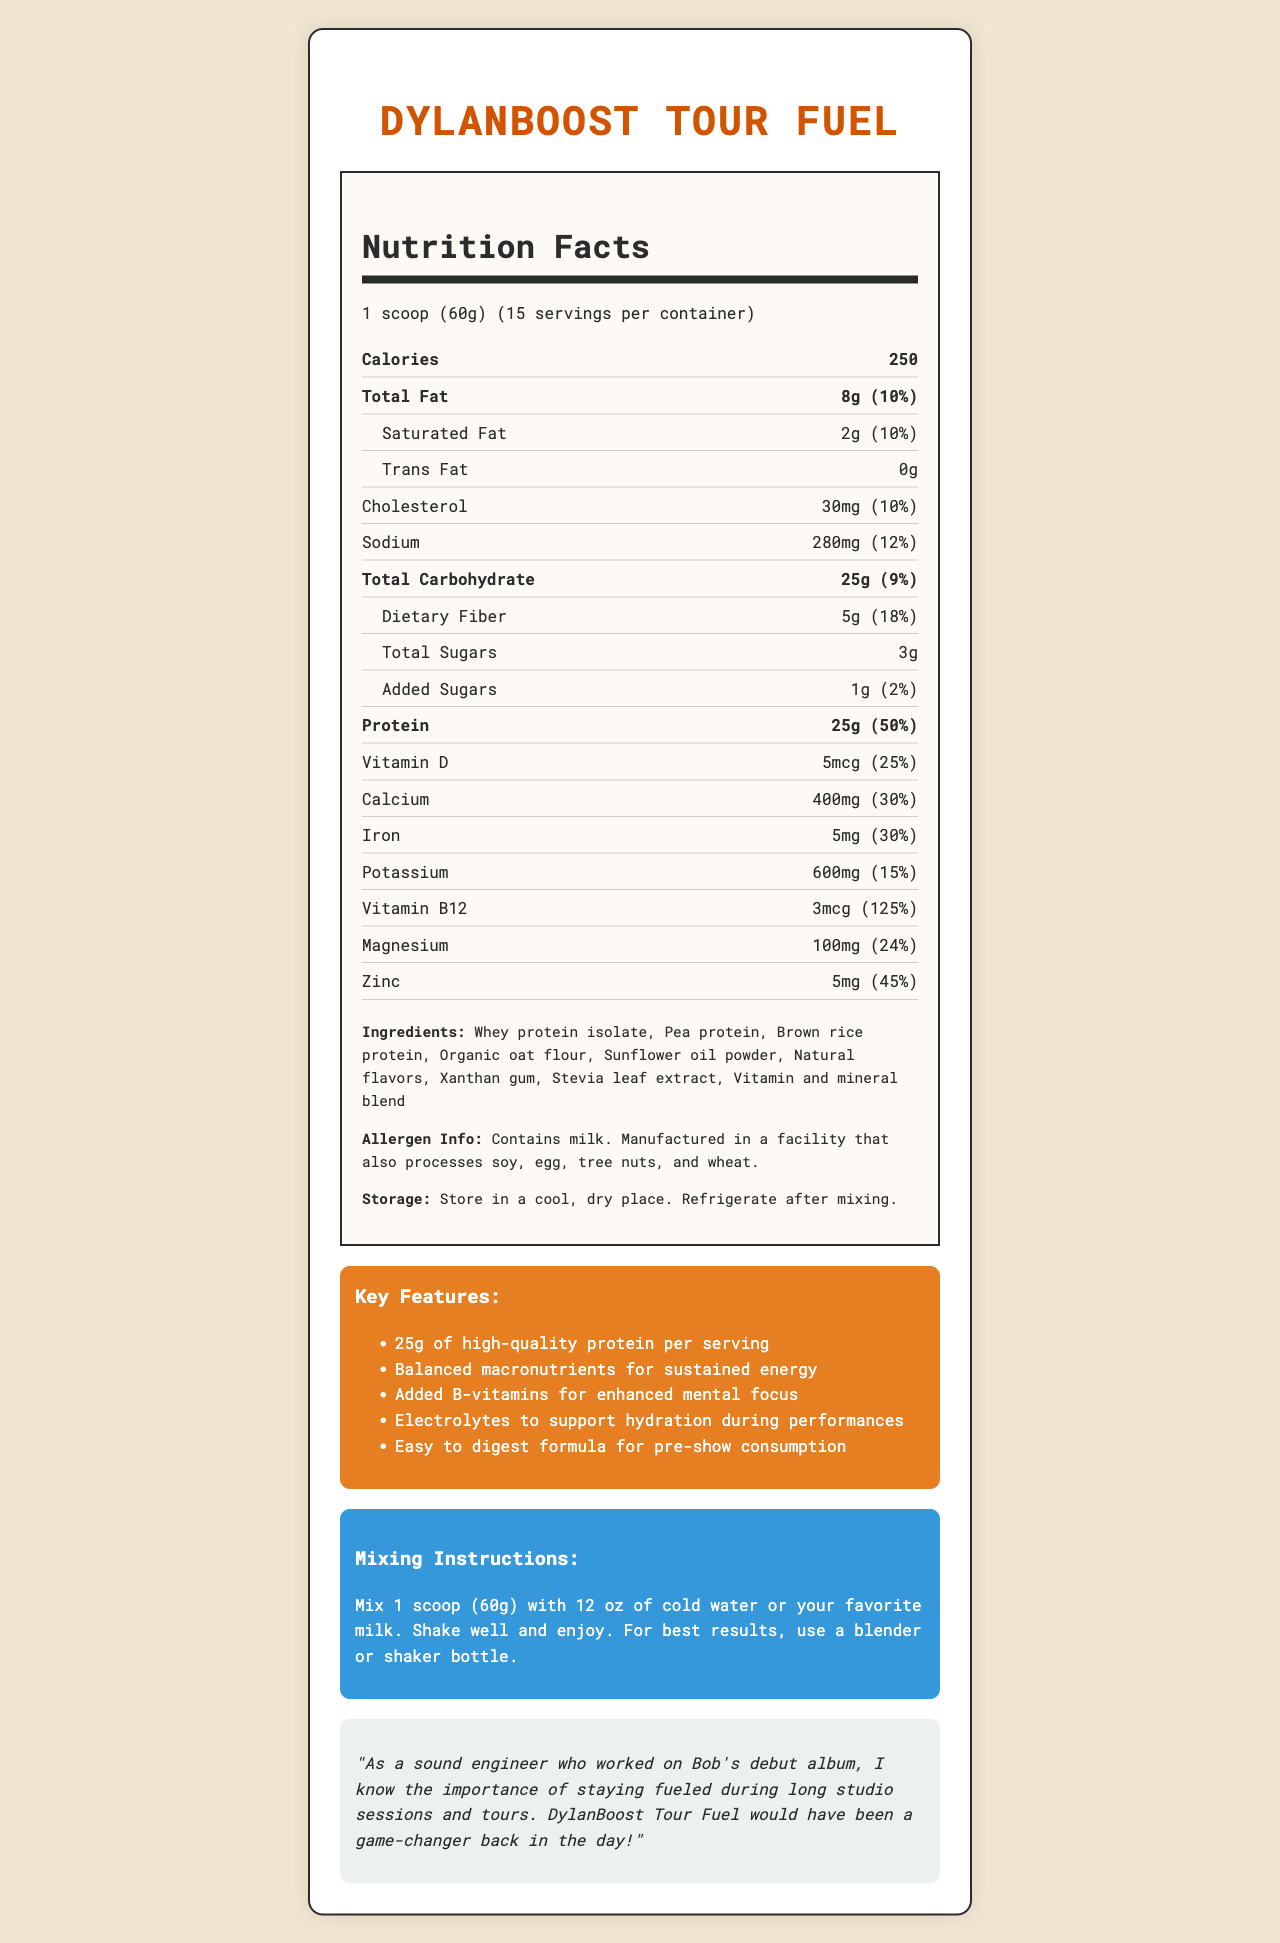what is the product name? The product name is listed at the top of the document as "DylanBoost Tour Fuel".
Answer: DylanBoost Tour Fuel how many servings are in one container? The document states that there are 15 servings per container.
Answer: 15 how many calories are per serving? The document lists 250 calories per serving.
Answer: 250 what is the amount of protein per serving? In the nutrition facts, it is specified that each serving contains 25g of protein.
Answer: 25g what allergens are present in the product? The allergen information section states that the product contains milk.
Answer: Contains milk. what percent of the daily value of vitamin D does one serving provide? The amount of vitamin D provided per serving is listed as 25% of the daily value.
Answer: 25% C. Brown rice protein Chicken protein is not listed as an ingredient, while Xanthan gum and Brown rice protein are included in the list.
Answer: B how much added sugar is in one serving? The nutrition facts specify that there is 1 gram of added sugar per serving.
Answer: 1g true or false: DylanBoost Tour Fuel contains soy. The allergen information states that it is manufactured in a facility that processes soy, but it does not contain soy itself.
Answer: False details about sodium? The document states that one serving has 280 mg of sodium, which is 12% of the daily value.
Answer: 280 mg, 12% of daily value what are the key features of DylanBoost Tour Fuel? These are the key features listed under the "Key Features" section of the document.
Answer: 25g of high-quality protein per serving, Balanced macronutrients for sustained energy, Added B-vitamins for enhanced mental focus, Electrolytes to support hydration during performances, Easy to digest formula for pre-show consumption how should DylanBoost Tour Fuel be stored? Instructions for storage state to store the product in a cool, dry place and to refrigerate after mixing.
Answer: Store in a cool, dry place. Refrigerate after mixing. what is the serving size of DylanBoost Tour Fuel? The serving size is listed as "1 scoop (60g)".
Answer: 1 scoop (60g) the product provides what percentage of the daily value of iron? The nutrition facts indicate that one serving provides 30% of the daily value of iron.
Answer: 30% how many grams of dietary fiber are there per serving? The document states that each serving contains 5 grams of dietary fiber.
Answer: 5g is there any trans fat in DylanBoost Tour Fuel? The nutrition facts clearly state that there is 0g of trans fat per serving.
Answer: No summarize the main idea of the document. The document provides detailed information about the product, including its nutrition facts, ingredients, key features, and handling instructions, emphasizing its suitability for musicians who need sustained energy and focus.
Answer: DylanBoost Tour Fuel is a meal replacement shake designed for musicians on tour, providing essential nutrients like protein, vitamins, and minerals, with special benefits such as mental focus, hydration support, and easy digestion. what is the main ingredient used in DylanBoost Tour Fuel? The document lists multiple ingredients, but it does not specify which is the "main" ingredient.
Answer: Cannot be determined 